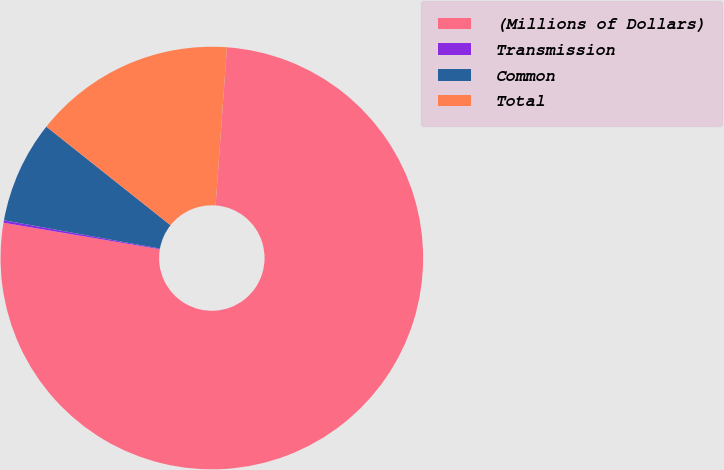Convert chart to OTSL. <chart><loc_0><loc_0><loc_500><loc_500><pie_chart><fcel>(Millions of Dollars)<fcel>Transmission<fcel>Common<fcel>Total<nl><fcel>76.53%<fcel>0.19%<fcel>7.82%<fcel>15.46%<nl></chart> 